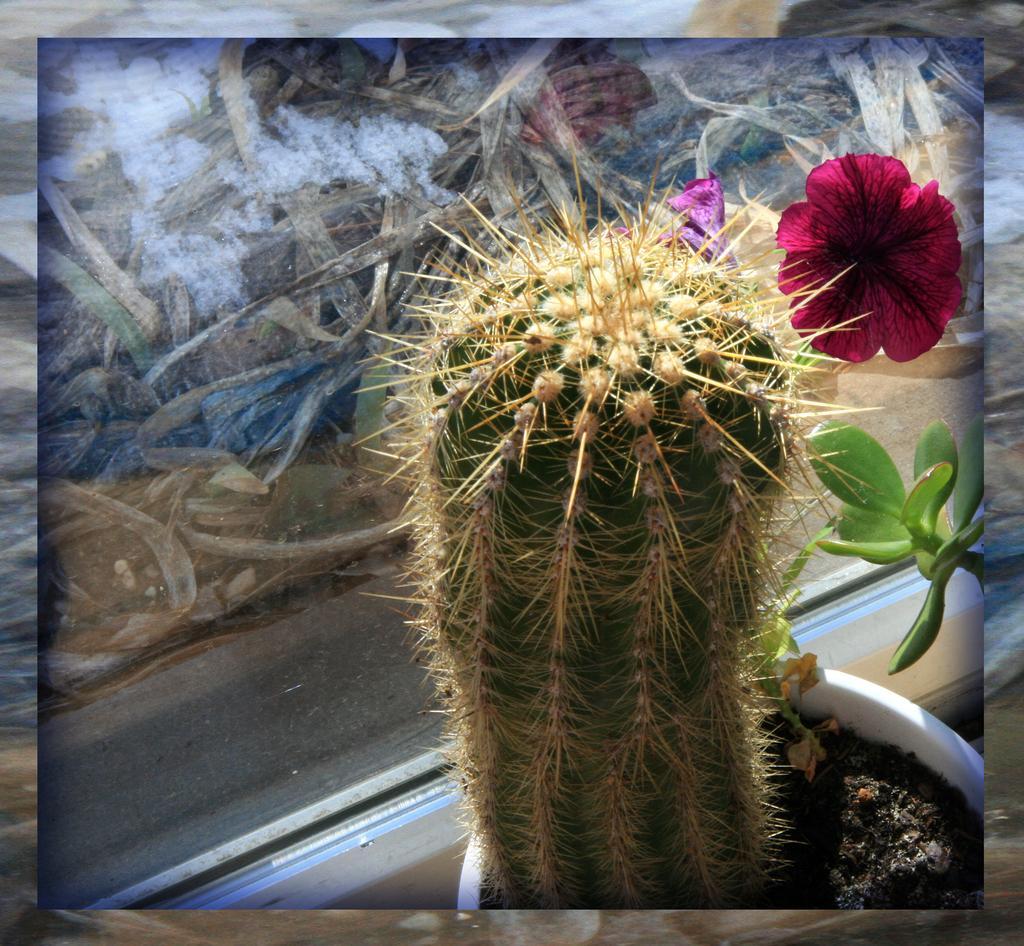Could you give a brief overview of what you see in this image? This is an edited image. We can see a plant in a pot, another plant and flowers and there are objects. In the background the image is not clear to describe. 